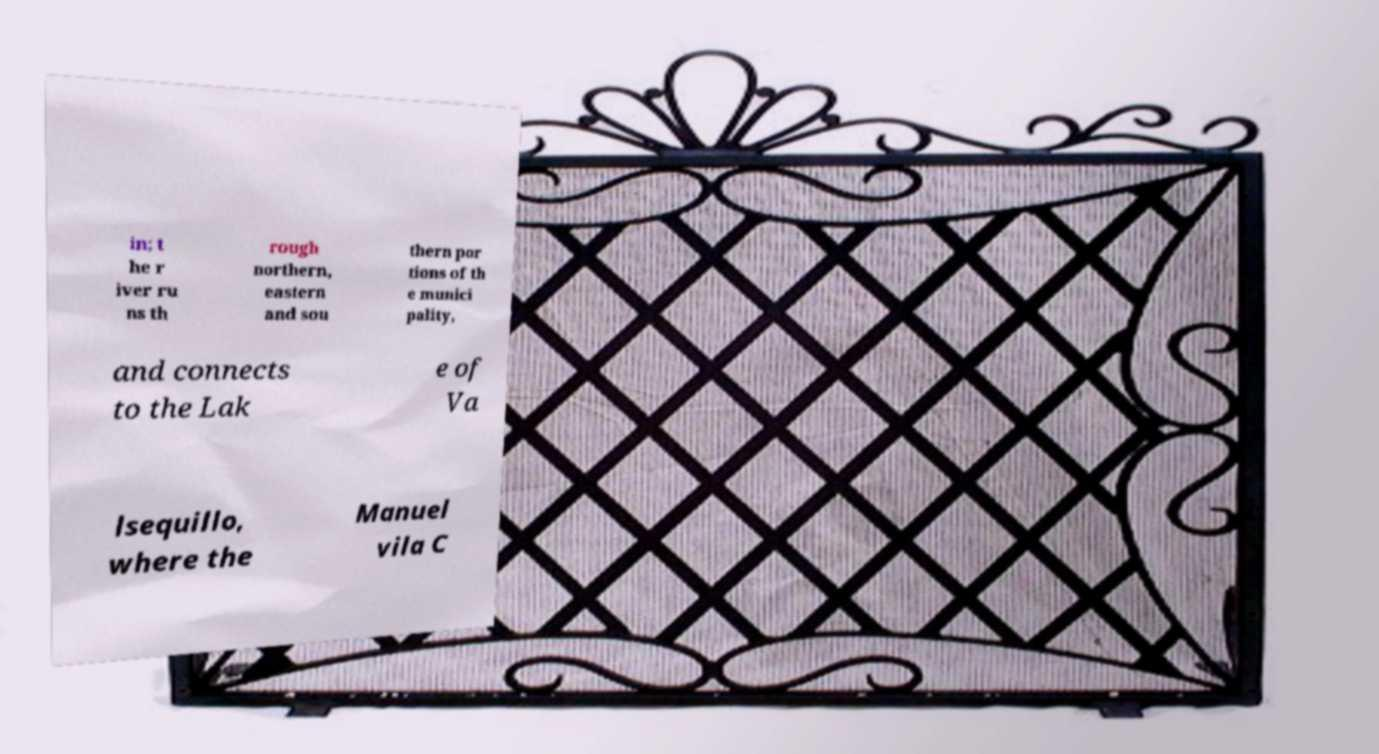I need the written content from this picture converted into text. Can you do that? in; t he r iver ru ns th rough northern, eastern and sou thern por tions of th e munici pality, and connects to the Lak e of Va lsequillo, where the Manuel vila C 